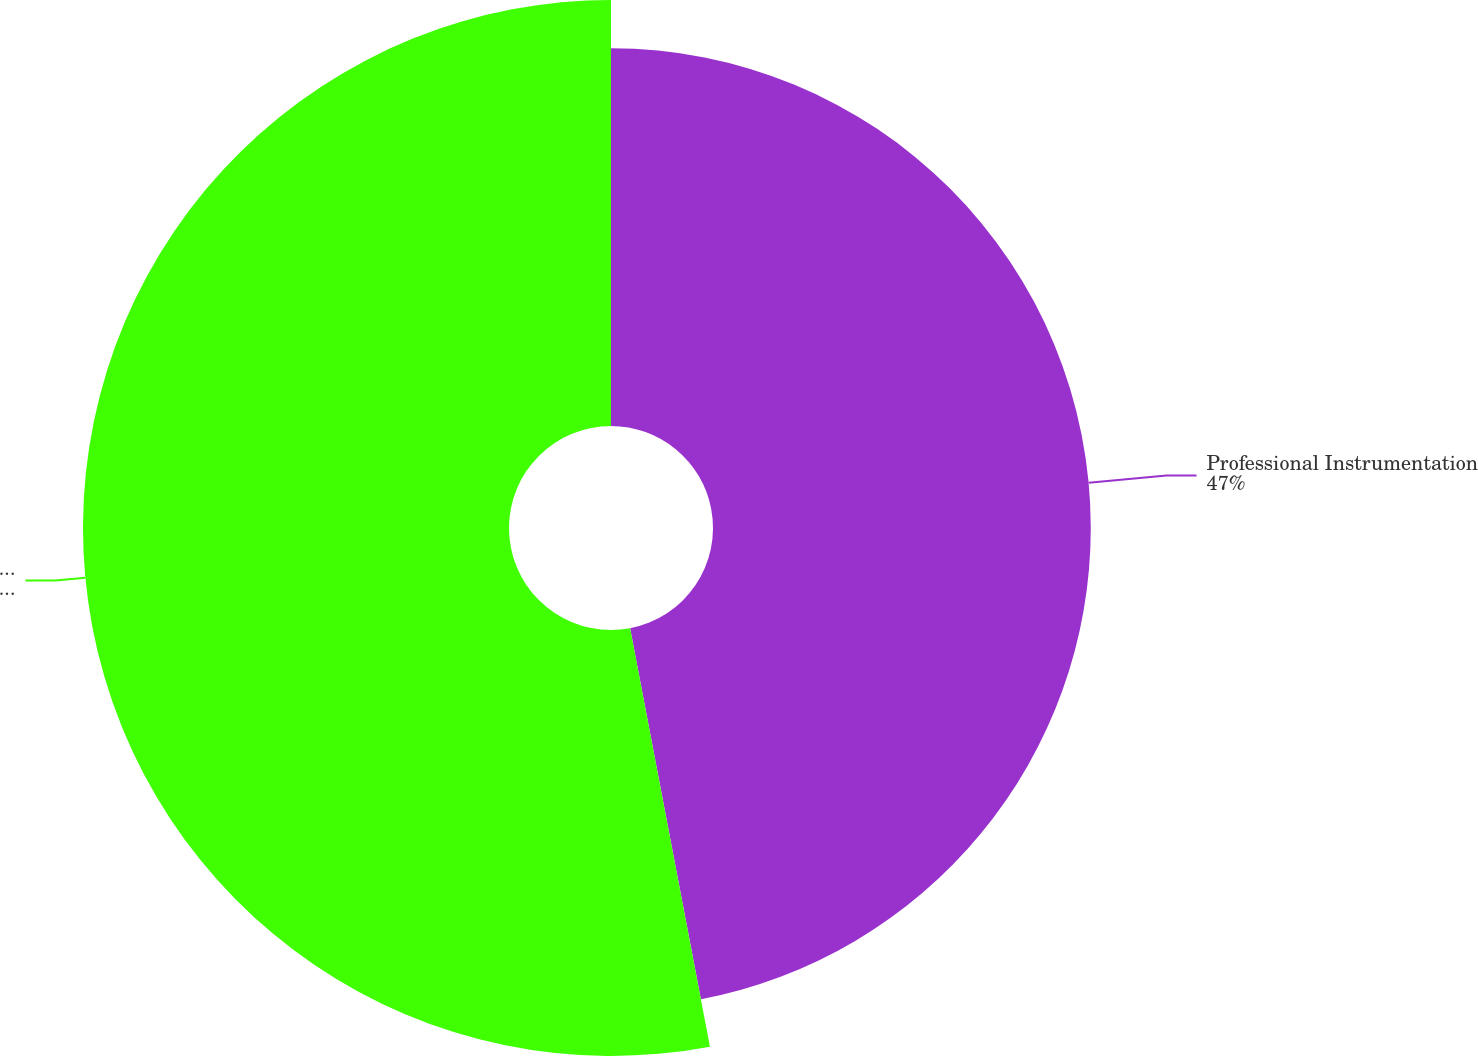<chart> <loc_0><loc_0><loc_500><loc_500><pie_chart><fcel>Professional Instrumentation<fcel>Industrial Technologies<nl><fcel>47.0%<fcel>53.0%<nl></chart> 